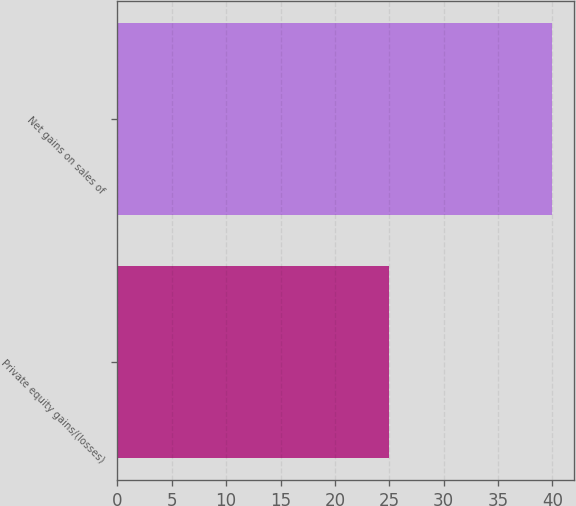<chart> <loc_0><loc_0><loc_500><loc_500><bar_chart><fcel>Private equity gains/(losses)<fcel>Net gains on sales of<nl><fcel>25<fcel>40<nl></chart> 